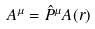<formula> <loc_0><loc_0><loc_500><loc_500>A ^ { \mu } = \hat { P } ^ { \mu } A ( r )</formula> 